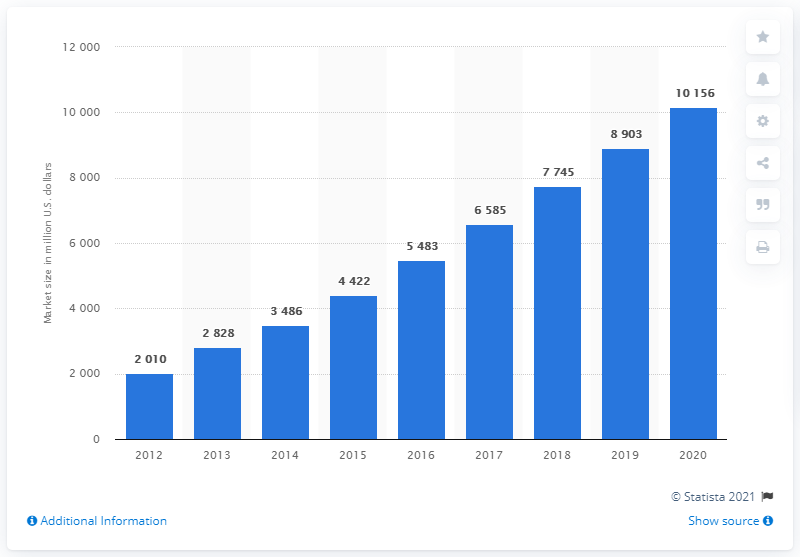Highlight a few significant elements in this photo. The lithium-ion battery market is projected to reach a total estimated value of $4,422 by 2015. 